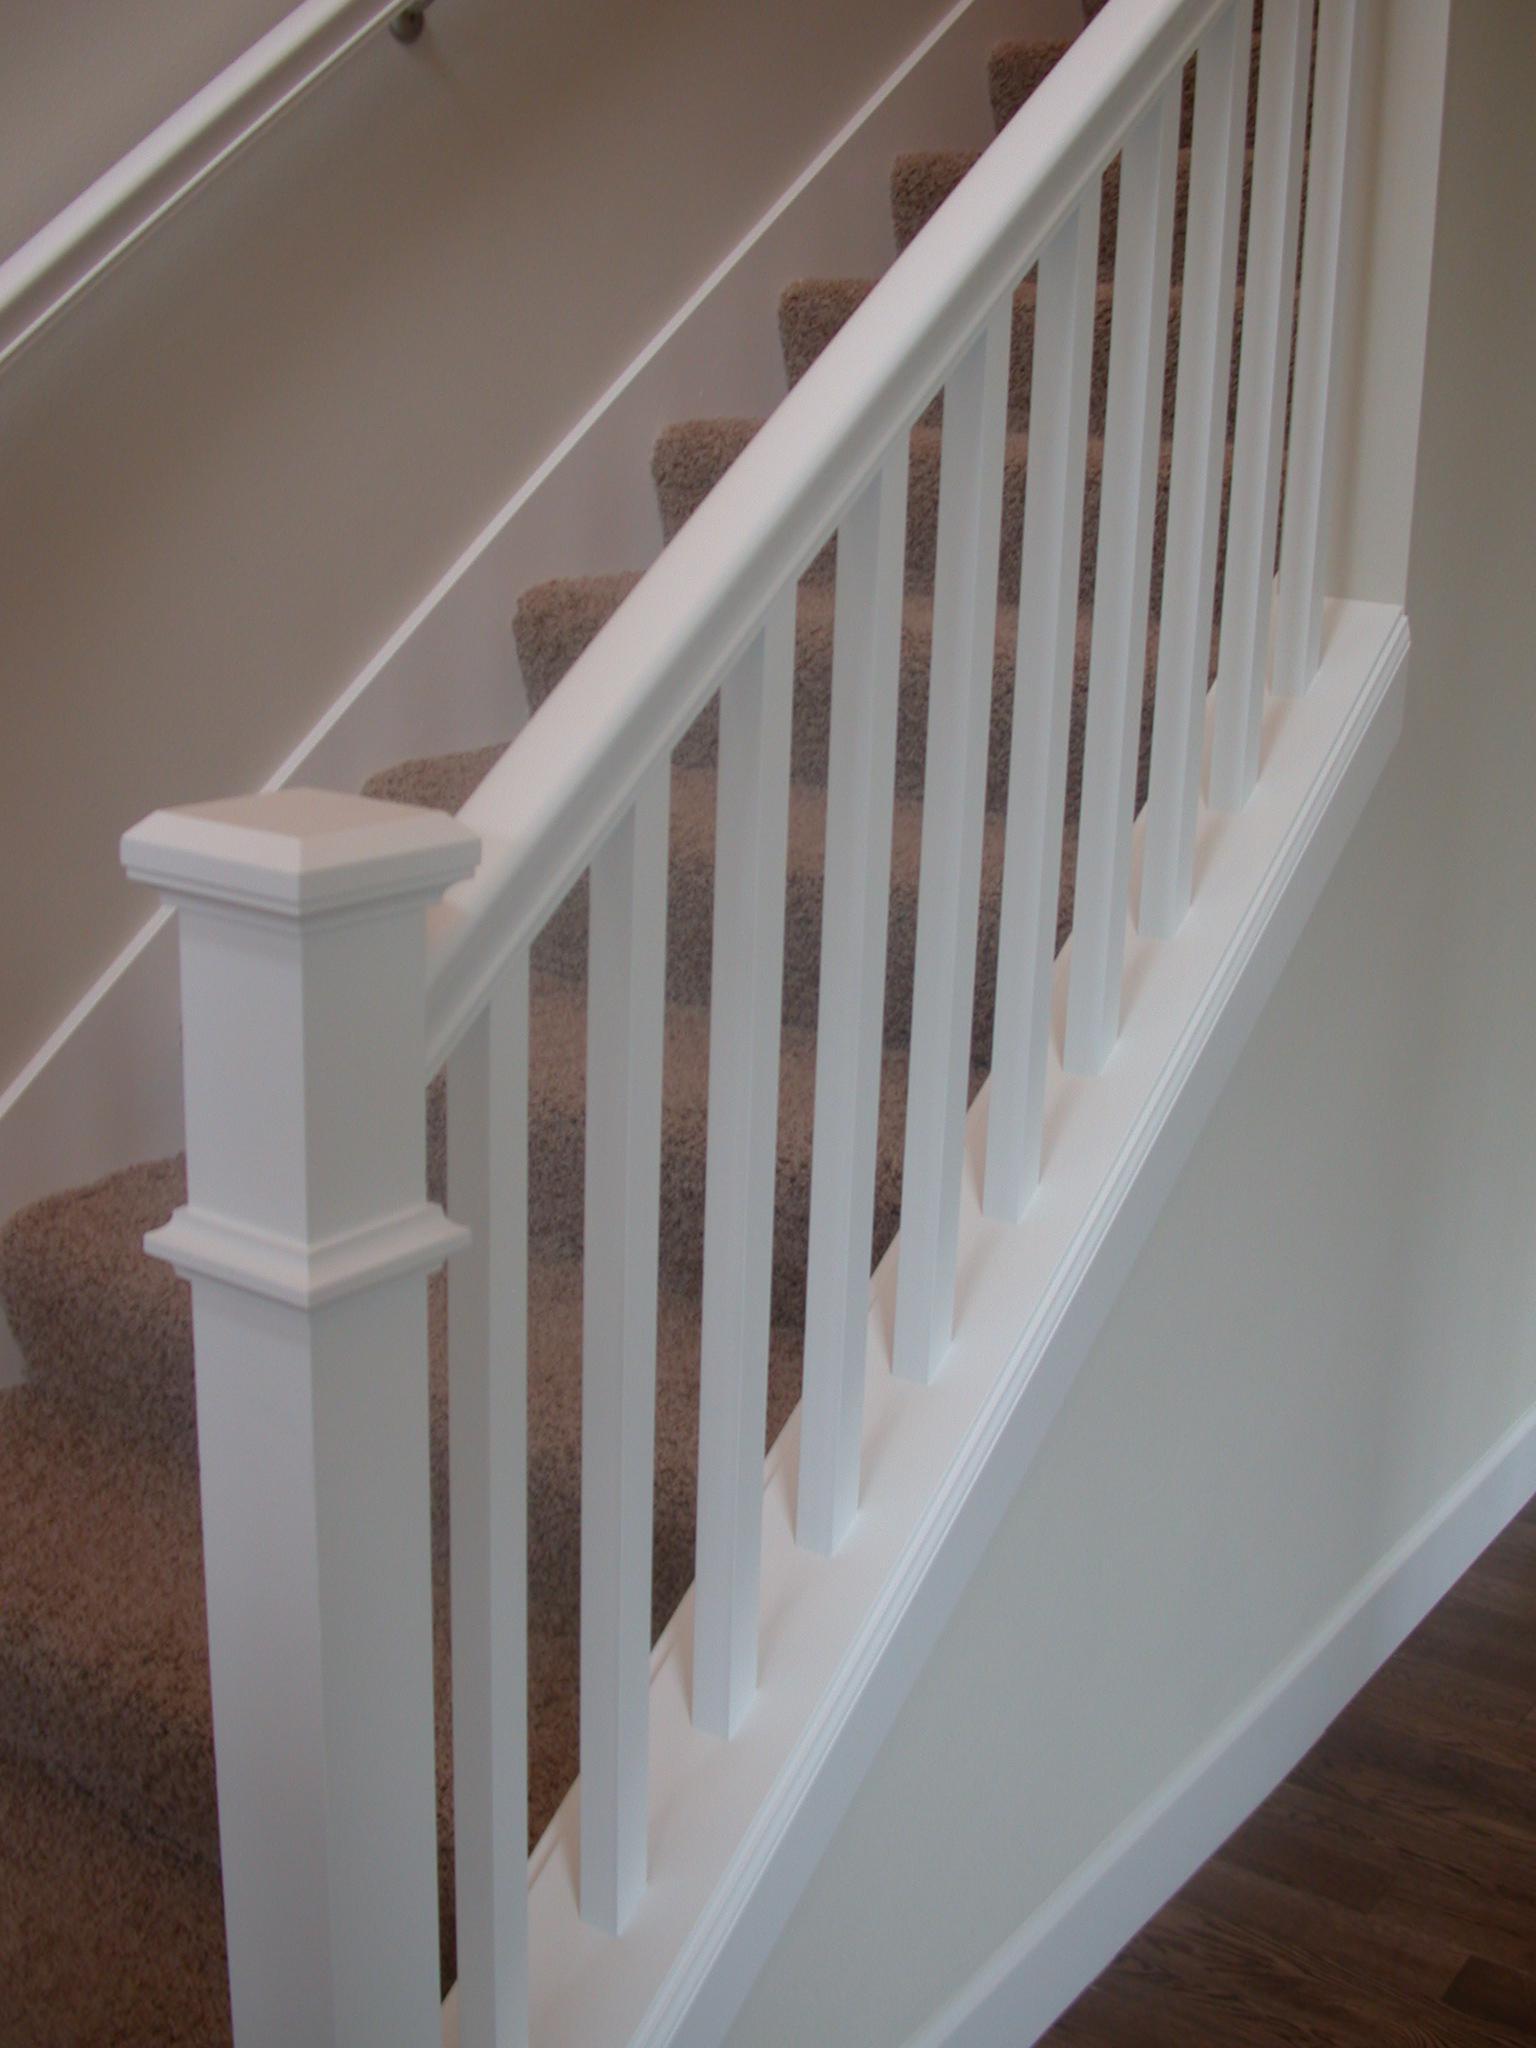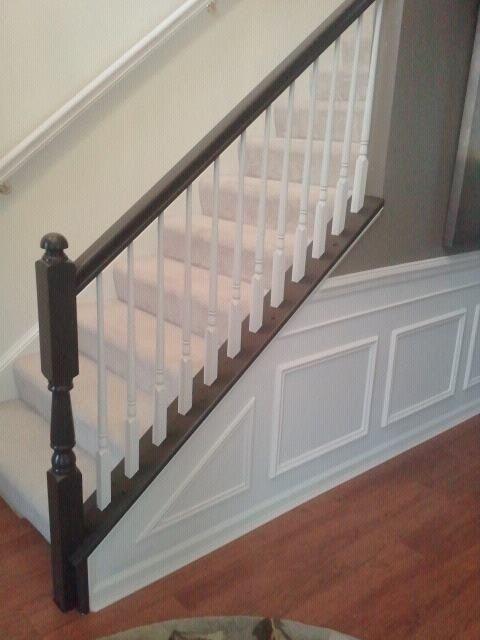The first image is the image on the left, the second image is the image on the right. Analyze the images presented: Is the assertion "In at least one image there are right facing stairs with black arm rails and white painted rods keeping it up." valid? Answer yes or no. Yes. The first image is the image on the left, the second image is the image on the right. Given the left and right images, does the statement "Each image shows a staircase that ascends to the right and has a wooden banister with only vertical bars and a closed-in bottom." hold true? Answer yes or no. Yes. 